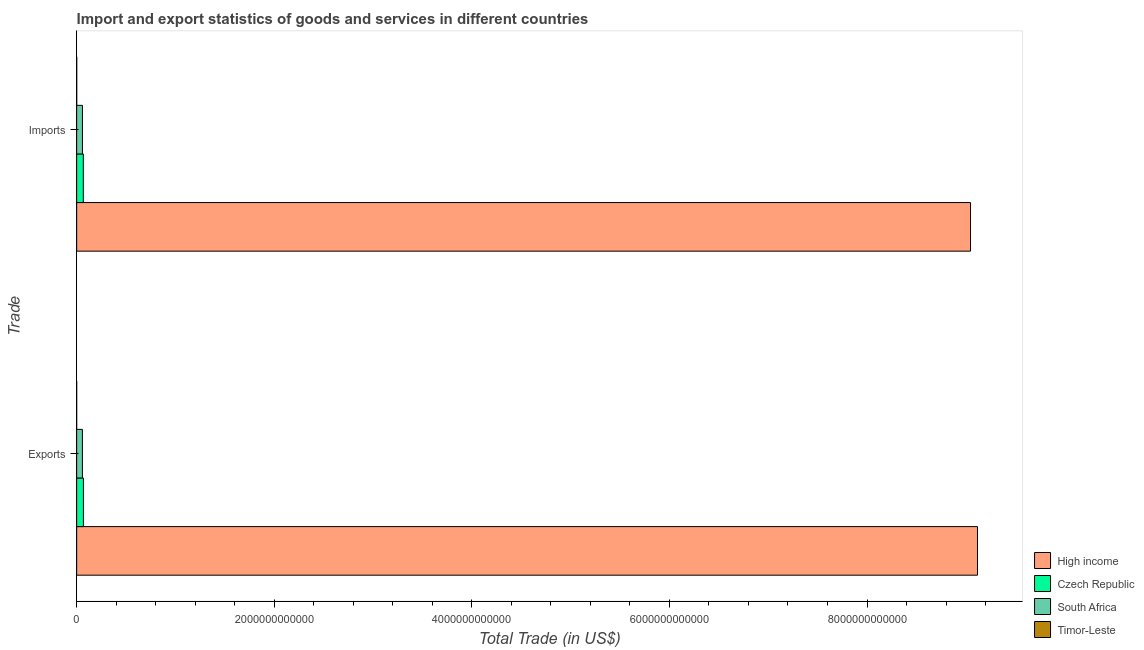How many different coloured bars are there?
Make the answer very short. 4. How many groups of bars are there?
Provide a succinct answer. 2. Are the number of bars on each tick of the Y-axis equal?
Ensure brevity in your answer.  Yes. How many bars are there on the 2nd tick from the top?
Provide a short and direct response. 4. How many bars are there on the 2nd tick from the bottom?
Offer a terse response. 4. What is the label of the 2nd group of bars from the top?
Give a very brief answer. Exports. What is the export of goods and services in Czech Republic?
Ensure brevity in your answer.  6.83e+1. Across all countries, what is the maximum export of goods and services?
Offer a very short reply. 9.12e+12. Across all countries, what is the minimum imports of goods and services?
Your answer should be compact. 4.41e+08. In which country was the imports of goods and services minimum?
Provide a short and direct response. Timor-Leste. What is the total export of goods and services in the graph?
Provide a short and direct response. 9.25e+12. What is the difference between the export of goods and services in South Africa and that in High income?
Offer a terse response. -9.06e+12. What is the difference between the imports of goods and services in High income and the export of goods and services in Timor-Leste?
Keep it short and to the point. 9.05e+12. What is the average imports of goods and services per country?
Ensure brevity in your answer.  2.29e+12. What is the difference between the imports of goods and services and export of goods and services in High income?
Make the answer very short. -7.07e+1. In how many countries, is the export of goods and services greater than 6000000000000 US$?
Ensure brevity in your answer.  1. What is the ratio of the imports of goods and services in Timor-Leste to that in South Africa?
Provide a short and direct response. 0.01. Is the export of goods and services in Czech Republic less than that in Timor-Leste?
Provide a short and direct response. No. What does the 1st bar from the top in Imports represents?
Provide a succinct answer. Timor-Leste. What does the 4th bar from the bottom in Exports represents?
Make the answer very short. Timor-Leste. How many bars are there?
Offer a terse response. 8. How many countries are there in the graph?
Keep it short and to the point. 4. What is the difference between two consecutive major ticks on the X-axis?
Keep it short and to the point. 2.00e+12. Does the graph contain any zero values?
Give a very brief answer. No. Does the graph contain grids?
Make the answer very short. No. Where does the legend appear in the graph?
Your answer should be very brief. Bottom right. How many legend labels are there?
Keep it short and to the point. 4. What is the title of the graph?
Your answer should be compact. Import and export statistics of goods and services in different countries. What is the label or title of the X-axis?
Make the answer very short. Total Trade (in US$). What is the label or title of the Y-axis?
Your answer should be very brief. Trade. What is the Total Trade (in US$) of High income in Exports?
Your answer should be compact. 9.12e+12. What is the Total Trade (in US$) of Czech Republic in Exports?
Offer a terse response. 6.83e+1. What is the Total Trade (in US$) in South Africa in Exports?
Your response must be concise. 5.82e+1. What is the Total Trade (in US$) in Timor-Leste in Exports?
Give a very brief answer. 3.90e+07. What is the Total Trade (in US$) of High income in Imports?
Your answer should be very brief. 9.05e+12. What is the Total Trade (in US$) of Czech Republic in Imports?
Offer a terse response. 6.74e+1. What is the Total Trade (in US$) of South Africa in Imports?
Your answer should be compact. 5.85e+1. What is the Total Trade (in US$) in Timor-Leste in Imports?
Your response must be concise. 4.41e+08. Across all Trade, what is the maximum Total Trade (in US$) of High income?
Your answer should be very brief. 9.12e+12. Across all Trade, what is the maximum Total Trade (in US$) of Czech Republic?
Provide a short and direct response. 6.83e+1. Across all Trade, what is the maximum Total Trade (in US$) in South Africa?
Ensure brevity in your answer.  5.85e+1. Across all Trade, what is the maximum Total Trade (in US$) in Timor-Leste?
Keep it short and to the point. 4.41e+08. Across all Trade, what is the minimum Total Trade (in US$) in High income?
Your response must be concise. 9.05e+12. Across all Trade, what is the minimum Total Trade (in US$) of Czech Republic?
Provide a succinct answer. 6.74e+1. Across all Trade, what is the minimum Total Trade (in US$) in South Africa?
Keep it short and to the point. 5.82e+1. Across all Trade, what is the minimum Total Trade (in US$) in Timor-Leste?
Offer a very short reply. 3.90e+07. What is the total Total Trade (in US$) in High income in the graph?
Ensure brevity in your answer.  1.82e+13. What is the total Total Trade (in US$) in Czech Republic in the graph?
Offer a very short reply. 1.36e+11. What is the total Total Trade (in US$) of South Africa in the graph?
Provide a short and direct response. 1.17e+11. What is the total Total Trade (in US$) of Timor-Leste in the graph?
Offer a very short reply. 4.80e+08. What is the difference between the Total Trade (in US$) in High income in Exports and that in Imports?
Provide a succinct answer. 7.07e+1. What is the difference between the Total Trade (in US$) in Czech Republic in Exports and that in Imports?
Your answer should be very brief. 9.68e+08. What is the difference between the Total Trade (in US$) in South Africa in Exports and that in Imports?
Provide a succinct answer. -3.29e+08. What is the difference between the Total Trade (in US$) of Timor-Leste in Exports and that in Imports?
Ensure brevity in your answer.  -4.02e+08. What is the difference between the Total Trade (in US$) of High income in Exports and the Total Trade (in US$) of Czech Republic in Imports?
Your answer should be very brief. 9.05e+12. What is the difference between the Total Trade (in US$) in High income in Exports and the Total Trade (in US$) in South Africa in Imports?
Ensure brevity in your answer.  9.06e+12. What is the difference between the Total Trade (in US$) in High income in Exports and the Total Trade (in US$) in Timor-Leste in Imports?
Provide a short and direct response. 9.12e+12. What is the difference between the Total Trade (in US$) in Czech Republic in Exports and the Total Trade (in US$) in South Africa in Imports?
Your response must be concise. 9.78e+09. What is the difference between the Total Trade (in US$) in Czech Republic in Exports and the Total Trade (in US$) in Timor-Leste in Imports?
Ensure brevity in your answer.  6.79e+1. What is the difference between the Total Trade (in US$) of South Africa in Exports and the Total Trade (in US$) of Timor-Leste in Imports?
Offer a terse response. 5.78e+1. What is the average Total Trade (in US$) of High income per Trade?
Make the answer very short. 9.08e+12. What is the average Total Trade (in US$) of Czech Republic per Trade?
Keep it short and to the point. 6.78e+1. What is the average Total Trade (in US$) of South Africa per Trade?
Your answer should be compact. 5.84e+1. What is the average Total Trade (in US$) of Timor-Leste per Trade?
Offer a very short reply. 2.40e+08. What is the difference between the Total Trade (in US$) of High income and Total Trade (in US$) of Czech Republic in Exports?
Your response must be concise. 9.05e+12. What is the difference between the Total Trade (in US$) of High income and Total Trade (in US$) of South Africa in Exports?
Provide a succinct answer. 9.06e+12. What is the difference between the Total Trade (in US$) of High income and Total Trade (in US$) of Timor-Leste in Exports?
Give a very brief answer. 9.12e+12. What is the difference between the Total Trade (in US$) of Czech Republic and Total Trade (in US$) of South Africa in Exports?
Your response must be concise. 1.01e+1. What is the difference between the Total Trade (in US$) of Czech Republic and Total Trade (in US$) of Timor-Leste in Exports?
Provide a succinct answer. 6.83e+1. What is the difference between the Total Trade (in US$) of South Africa and Total Trade (in US$) of Timor-Leste in Exports?
Your response must be concise. 5.82e+1. What is the difference between the Total Trade (in US$) in High income and Total Trade (in US$) in Czech Republic in Imports?
Your response must be concise. 8.98e+12. What is the difference between the Total Trade (in US$) in High income and Total Trade (in US$) in South Africa in Imports?
Offer a very short reply. 8.99e+12. What is the difference between the Total Trade (in US$) of High income and Total Trade (in US$) of Timor-Leste in Imports?
Offer a terse response. 9.05e+12. What is the difference between the Total Trade (in US$) of Czech Republic and Total Trade (in US$) of South Africa in Imports?
Your answer should be compact. 8.81e+09. What is the difference between the Total Trade (in US$) in Czech Republic and Total Trade (in US$) in Timor-Leste in Imports?
Provide a short and direct response. 6.69e+1. What is the difference between the Total Trade (in US$) in South Africa and Total Trade (in US$) in Timor-Leste in Imports?
Your answer should be compact. 5.81e+1. What is the ratio of the Total Trade (in US$) of High income in Exports to that in Imports?
Offer a terse response. 1.01. What is the ratio of the Total Trade (in US$) of Czech Republic in Exports to that in Imports?
Your answer should be compact. 1.01. What is the ratio of the Total Trade (in US$) of Timor-Leste in Exports to that in Imports?
Make the answer very short. 0.09. What is the difference between the highest and the second highest Total Trade (in US$) in High income?
Your response must be concise. 7.07e+1. What is the difference between the highest and the second highest Total Trade (in US$) in Czech Republic?
Your answer should be compact. 9.68e+08. What is the difference between the highest and the second highest Total Trade (in US$) of South Africa?
Give a very brief answer. 3.29e+08. What is the difference between the highest and the second highest Total Trade (in US$) of Timor-Leste?
Your answer should be compact. 4.02e+08. What is the difference between the highest and the lowest Total Trade (in US$) in High income?
Offer a terse response. 7.07e+1. What is the difference between the highest and the lowest Total Trade (in US$) in Czech Republic?
Your answer should be very brief. 9.68e+08. What is the difference between the highest and the lowest Total Trade (in US$) of South Africa?
Offer a very short reply. 3.29e+08. What is the difference between the highest and the lowest Total Trade (in US$) in Timor-Leste?
Make the answer very short. 4.02e+08. 